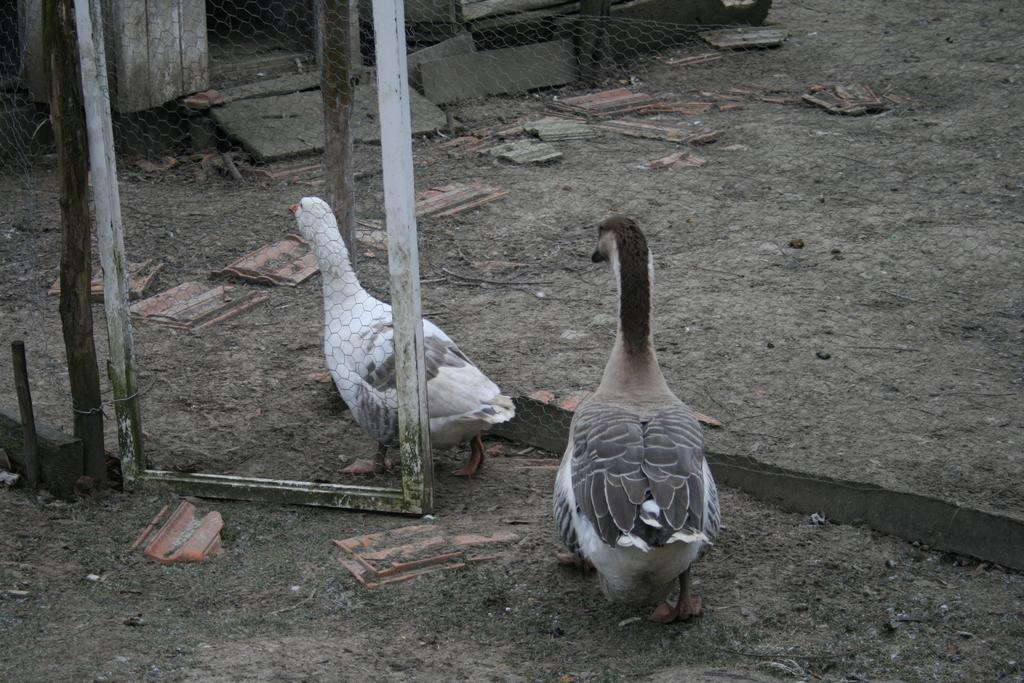How many birds are present in the image? There are 2 birds in the image. What colors can be seen on the birds? The birds are of white, grey, and brown color. Where are the birds located in the image? The birds are on the ground. What can be seen in the background of the image? There is fencing visible in the background of the image, as well as other unspecified objects. Can you hear the music playing in the background of the image? There is no mention of music or any sound in the image, so it cannot be heard. 